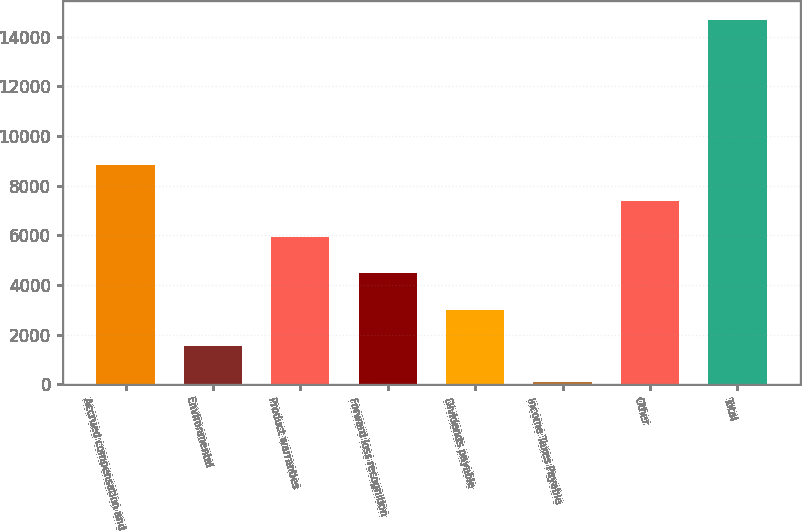<chart> <loc_0><loc_0><loc_500><loc_500><bar_chart><fcel>Accrued compensation and<fcel>Environmental<fcel>Product warranties<fcel>Forward loss recognition<fcel>Dividends payable<fcel>Income Taxes Payable<fcel>Other<fcel>Total<nl><fcel>8850.2<fcel>1549.2<fcel>5929.8<fcel>4469.6<fcel>3009.4<fcel>89<fcel>7390<fcel>14691<nl></chart> 